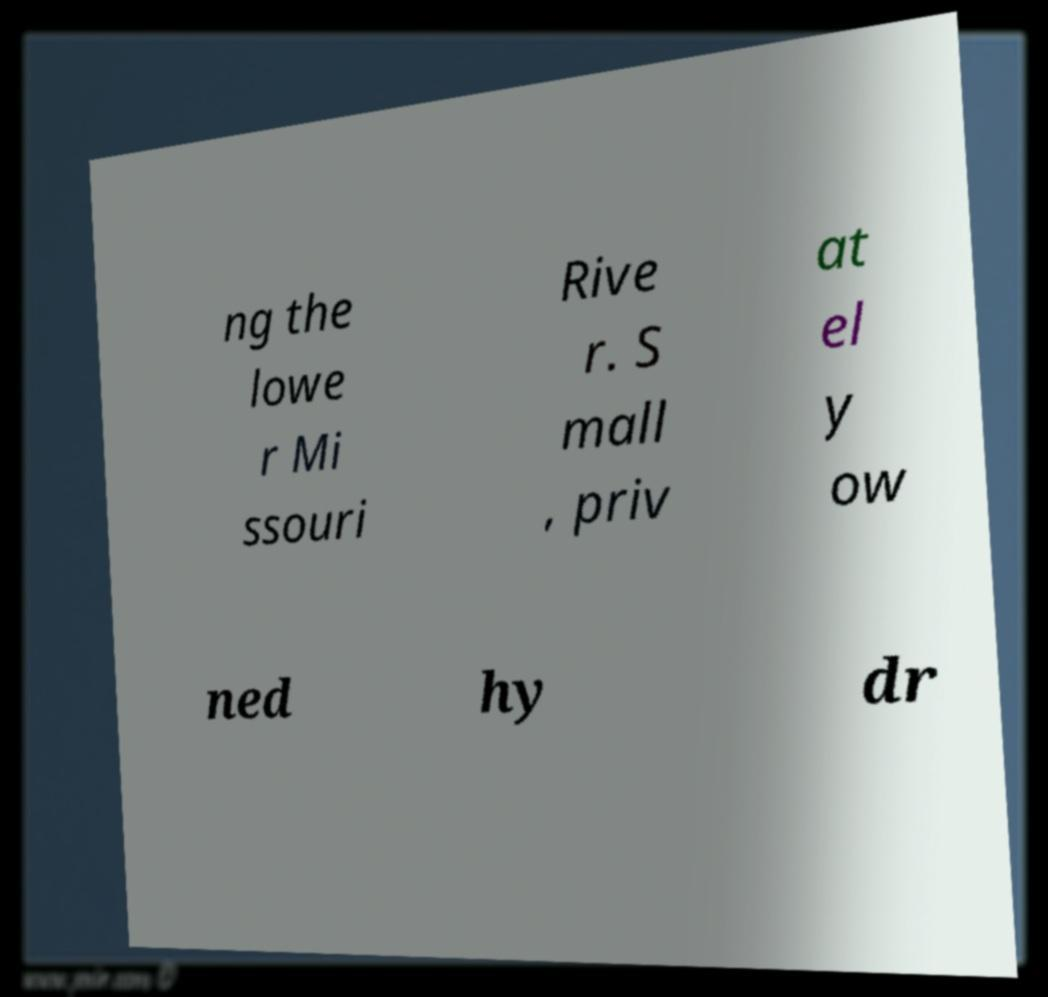Please read and relay the text visible in this image. What does it say? ng the lowe r Mi ssouri Rive r. S mall , priv at el y ow ned hy dr 